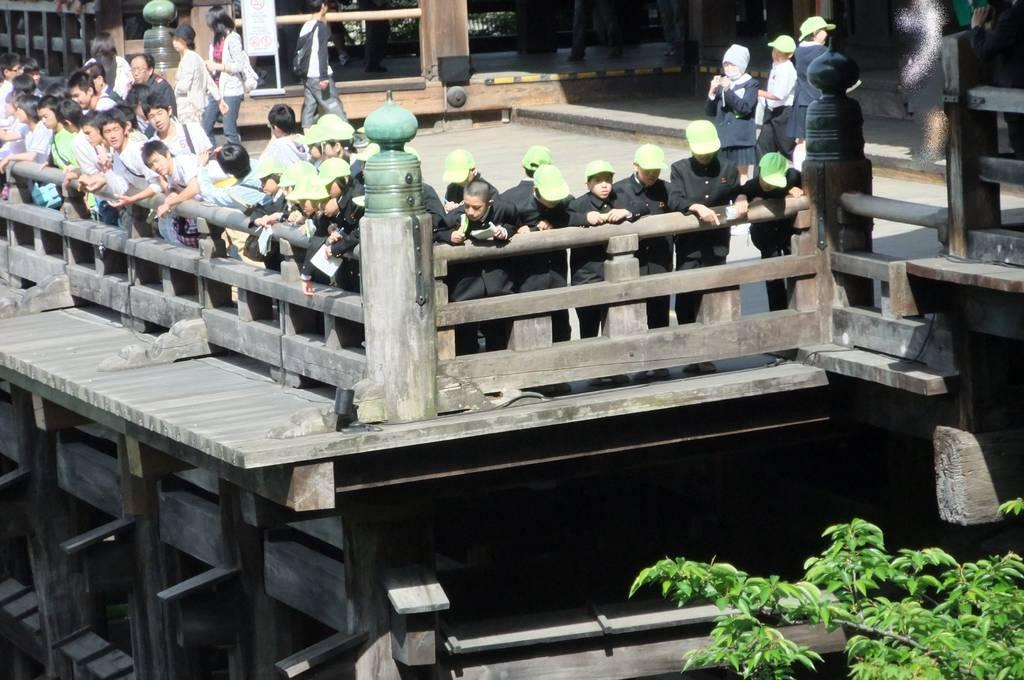What type of barrier is visible in the image? There is a wooden boundary in the image. Who or what is behind the wooden boundary? There are people standing behind the boundary. Is there any vegetation visible in the image? Yes, a tree is present in the bottom right corner of the image. What type of stamp can be seen on the tree in the image? There is no stamp present on the tree in the image; it is a regular tree. 